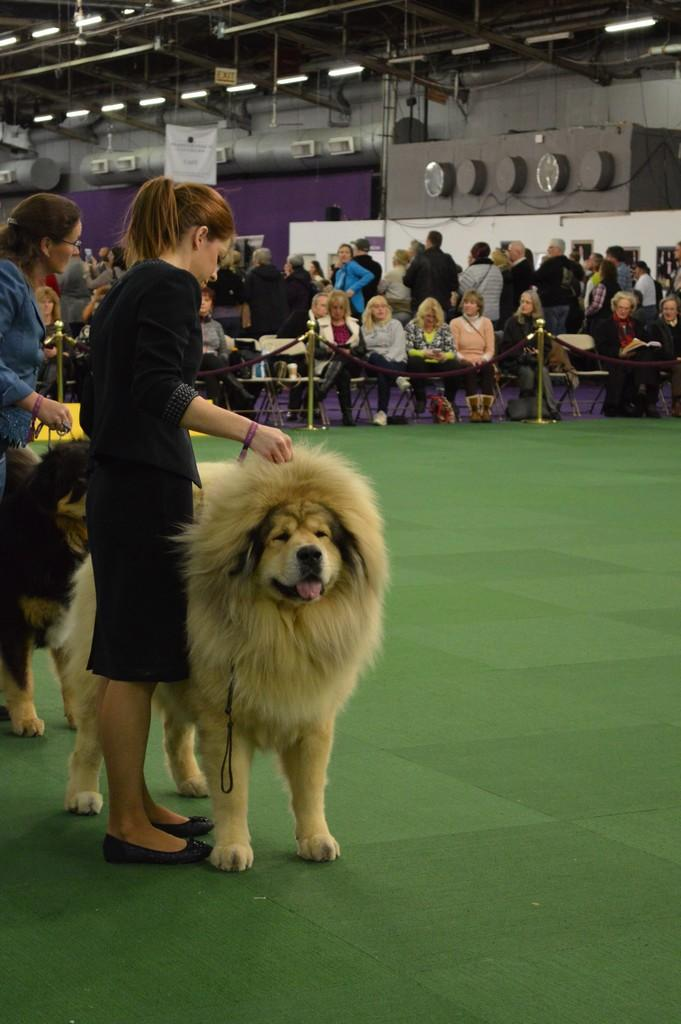How many people are in the image? There are two persons in the image. What are the two persons doing? The two persons are catching dogs. How are they catching the dogs? They are using leashes to catch the dogs. What can be observed in the background of the image? There are people sitting and standing in the background of the image. What sign can be seen in the image that indicates the need for addition? There is no sign present in the image that indicates the need for addition. 